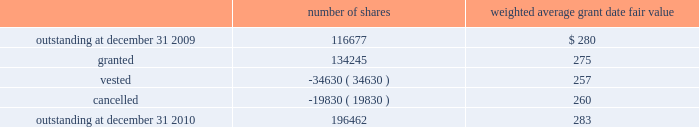The company granted 1020 performance shares .
The vesting of these shares is contingent on meeting stated goals over a performance period .
Beginning with restricted stock grants in september 2010 , dividends are accrued on restricted class a common stock and restricted stock units and are paid once the restricted stock vests .
The table summarizes restricted stock and performance shares activity for 2010 : number of shares weighted average grant date fair value .
The total fair value of restricted stock that vested during the years ended december 31 , 2010 , 2009 and 2008 , was $ 10.3 million , $ 6.2 million and $ 2.5 million , respectively .
Eligible employees may acquire shares of cme group 2019s class a common stock using after-tax payroll deductions made during consecutive offering periods of approximately six months in duration .
Shares are purchased at the end of each offering period at a price of 90% ( 90 % ) of the closing price of the class a common stock as reported on the nasdaq .
Compensation expense is recognized on the dates of purchase for the discount from the closing price .
In 2010 , 2009 and 2008 , a total of 4371 , 4402 and 5600 shares , respectively , of class a common stock were issued to participating employees .
These shares are subject to a six-month holding period .
Annual expense of $ 0.1 million for the purchase discount was recognized in 2010 , 2009 and 2008 , respectively .
Non-executive directors receive an annual award of class a common stock with a value equal to $ 75000 .
Non-executive directors may also elect to receive some or all of the cash portion of their annual stipend , up to $ 25000 , in shares of stock based on the closing price at the date of distribution .
As a result , 7470 , 11674 and 5509 shares of class a common stock were issued to non-executive directors during 2010 , 2009 and 2008 , respectively .
These shares are not subject to any vesting restrictions .
Expense of $ 2.4 million , $ 2.5 million and $ 2.4 million related to these stock-based payments was recognized for the years ended december 31 , 2010 , 2009 and 2008 , respectively. .
For 2010 , assuming all of the outstanding restricted stock and performance shares were exercised , what would be the increase in stockholders equity? 
Computations: (196462 * 283)
Answer: 55598746.0. 